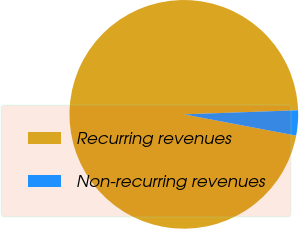Convert chart. <chart><loc_0><loc_0><loc_500><loc_500><pie_chart><fcel>Recurring revenues<fcel>Non-recurring revenues<nl><fcel>96.45%<fcel>3.55%<nl></chart> 